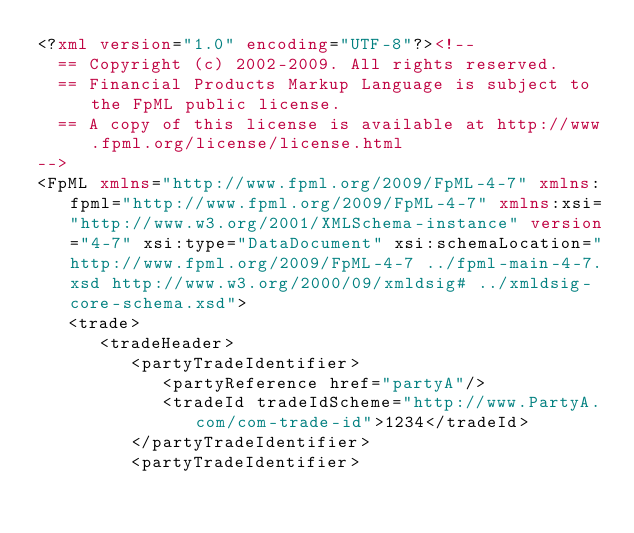Convert code to text. <code><loc_0><loc_0><loc_500><loc_500><_XML_><?xml version="1.0" encoding="UTF-8"?><!--
	== Copyright (c) 2002-2009. All rights reserved.
	== Financial Products Markup Language is subject to the FpML public license.
	== A copy of this license is available at http://www.fpml.org/license/license.html
-->
<FpML xmlns="http://www.fpml.org/2009/FpML-4-7" xmlns:fpml="http://www.fpml.org/2009/FpML-4-7" xmlns:xsi="http://www.w3.org/2001/XMLSchema-instance" version="4-7" xsi:type="DataDocument" xsi:schemaLocation="http://www.fpml.org/2009/FpML-4-7 ../fpml-main-4-7.xsd http://www.w3.org/2000/09/xmldsig# ../xmldsig-core-schema.xsd">
   <trade>
      <tradeHeader>
         <partyTradeIdentifier>
            <partyReference href="partyA"/>
            <tradeId tradeIdScheme="http://www.PartyA.com/com-trade-id">1234</tradeId>
         </partyTradeIdentifier>
         <partyTradeIdentifier></code> 